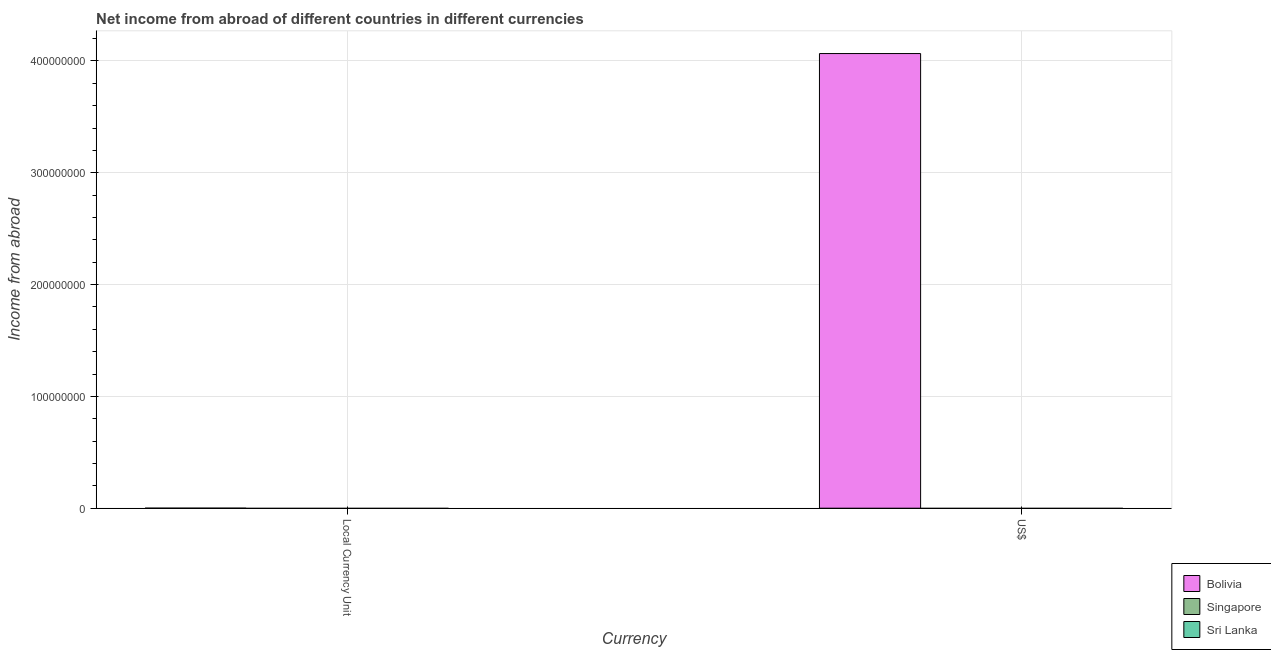How many different coloured bars are there?
Provide a short and direct response. 1. Are the number of bars on each tick of the X-axis equal?
Offer a very short reply. Yes. How many bars are there on the 2nd tick from the right?
Offer a very short reply. 1. What is the label of the 1st group of bars from the left?
Keep it short and to the point. Local Currency Unit. What is the income from abroad in constant 2005 us$ in Bolivia?
Provide a short and direct response. 9970.57. Across all countries, what is the maximum income from abroad in us$?
Keep it short and to the point. 4.07e+08. In which country was the income from abroad in constant 2005 us$ maximum?
Your answer should be very brief. Bolivia. What is the total income from abroad in us$ in the graph?
Your answer should be compact. 4.07e+08. What is the difference between the income from abroad in us$ in Sri Lanka and the income from abroad in constant 2005 us$ in Singapore?
Offer a very short reply. 0. What is the average income from abroad in us$ per country?
Your answer should be compact. 1.36e+08. What is the difference between the income from abroad in constant 2005 us$ and income from abroad in us$ in Bolivia?
Your answer should be compact. -4.07e+08. In how many countries, is the income from abroad in us$ greater than 120000000 units?
Keep it short and to the point. 1. Are the values on the major ticks of Y-axis written in scientific E-notation?
Provide a short and direct response. No. Does the graph contain grids?
Ensure brevity in your answer.  Yes. Where does the legend appear in the graph?
Your answer should be very brief. Bottom right. How many legend labels are there?
Offer a terse response. 3. How are the legend labels stacked?
Your response must be concise. Vertical. What is the title of the graph?
Your response must be concise. Net income from abroad of different countries in different currencies. What is the label or title of the X-axis?
Keep it short and to the point. Currency. What is the label or title of the Y-axis?
Make the answer very short. Income from abroad. What is the Income from abroad of Bolivia in Local Currency Unit?
Provide a succinct answer. 9970.57. What is the Income from abroad of Singapore in Local Currency Unit?
Give a very brief answer. 0. What is the Income from abroad of Sri Lanka in Local Currency Unit?
Your answer should be very brief. 0. What is the Income from abroad of Bolivia in US$?
Your answer should be compact. 4.07e+08. What is the Income from abroad in Sri Lanka in US$?
Provide a short and direct response. 0. Across all Currency, what is the maximum Income from abroad of Bolivia?
Your answer should be compact. 4.07e+08. Across all Currency, what is the minimum Income from abroad in Bolivia?
Your answer should be compact. 9970.57. What is the total Income from abroad in Bolivia in the graph?
Your answer should be compact. 4.07e+08. What is the total Income from abroad of Singapore in the graph?
Keep it short and to the point. 0. What is the total Income from abroad of Sri Lanka in the graph?
Your response must be concise. 0. What is the difference between the Income from abroad in Bolivia in Local Currency Unit and that in US$?
Make the answer very short. -4.07e+08. What is the average Income from abroad in Bolivia per Currency?
Offer a very short reply. 2.03e+08. What is the average Income from abroad in Singapore per Currency?
Give a very brief answer. 0. What is the ratio of the Income from abroad of Bolivia in Local Currency Unit to that in US$?
Ensure brevity in your answer.  0. What is the difference between the highest and the second highest Income from abroad of Bolivia?
Your answer should be compact. 4.07e+08. What is the difference between the highest and the lowest Income from abroad of Bolivia?
Ensure brevity in your answer.  4.07e+08. 